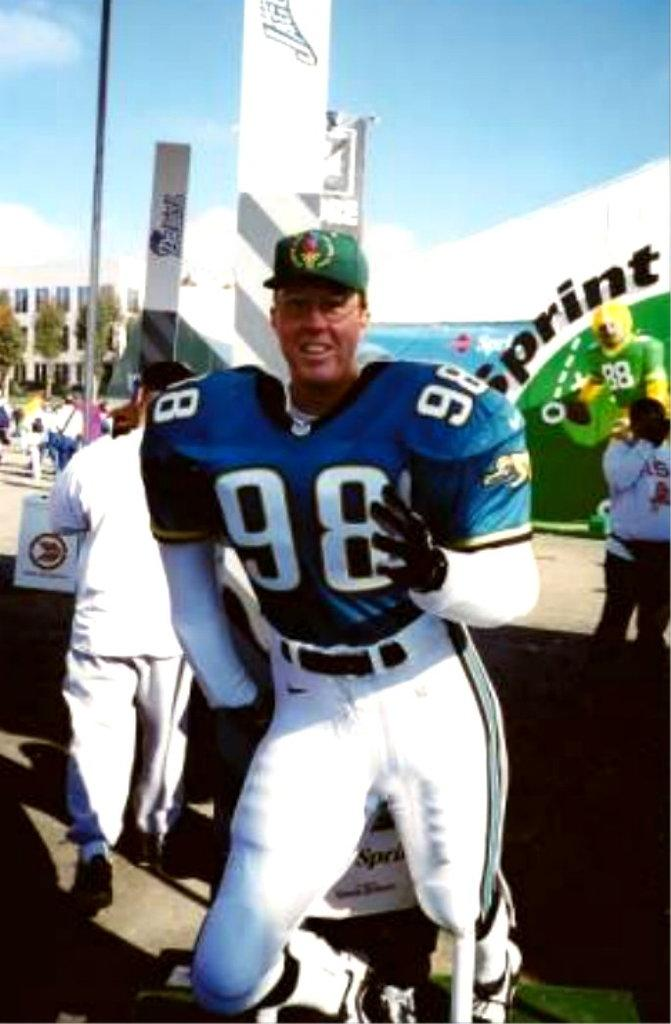<image>
Create a compact narrative representing the image presented. Football player with the number 98 posing for an event sponsored by Sprint. 